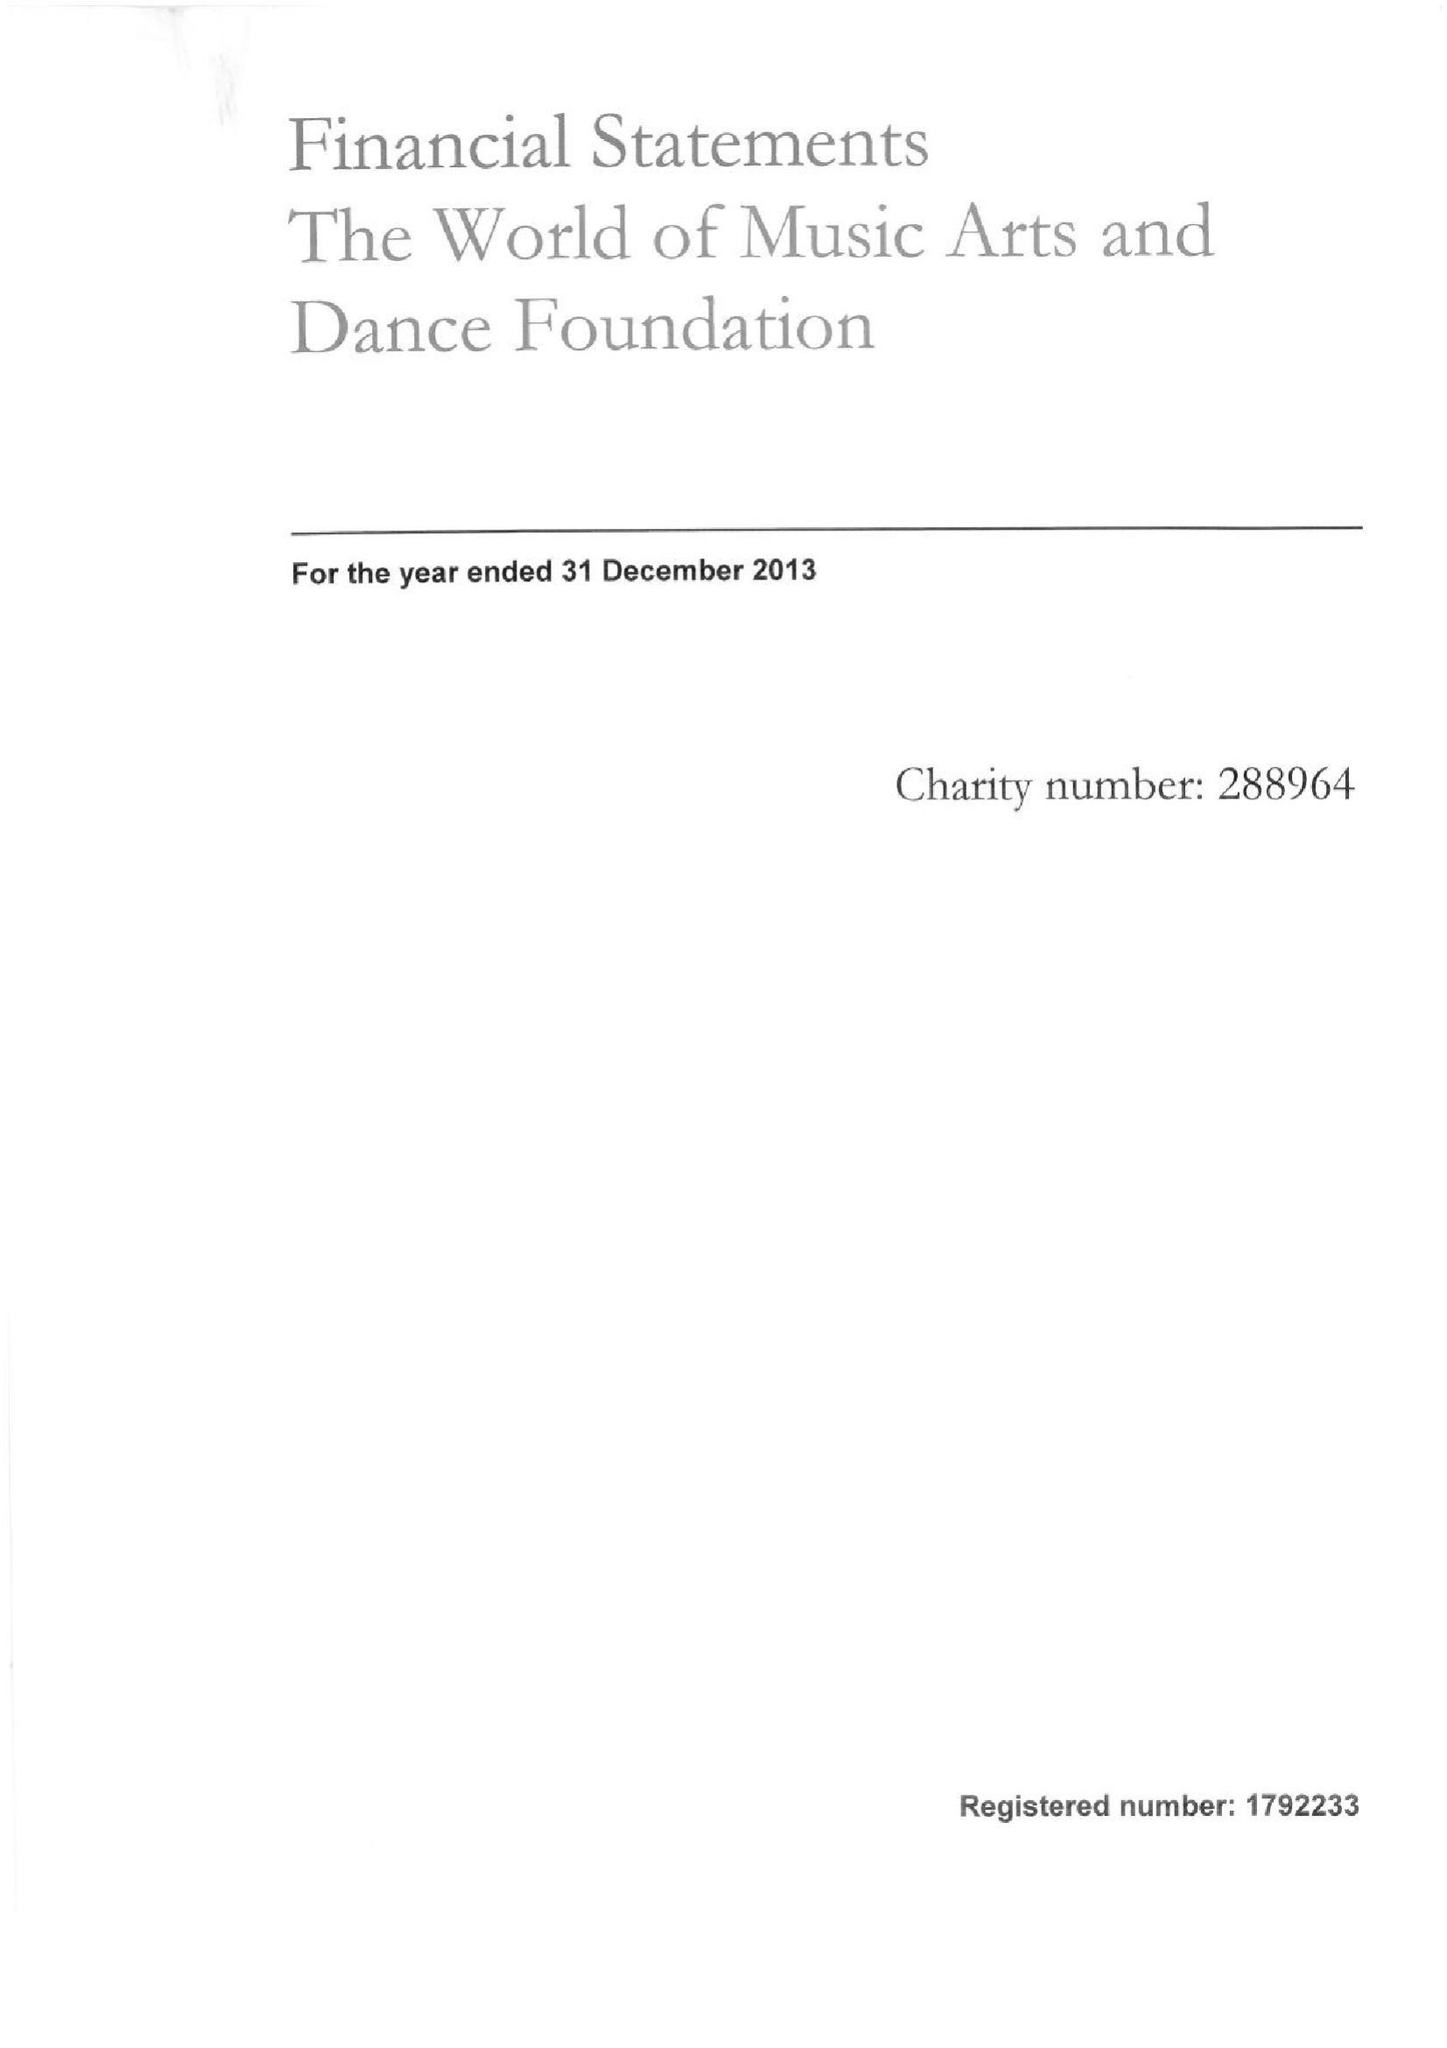What is the value for the address__street_line?
Answer the question using a single word or phrase. MILL LANE 